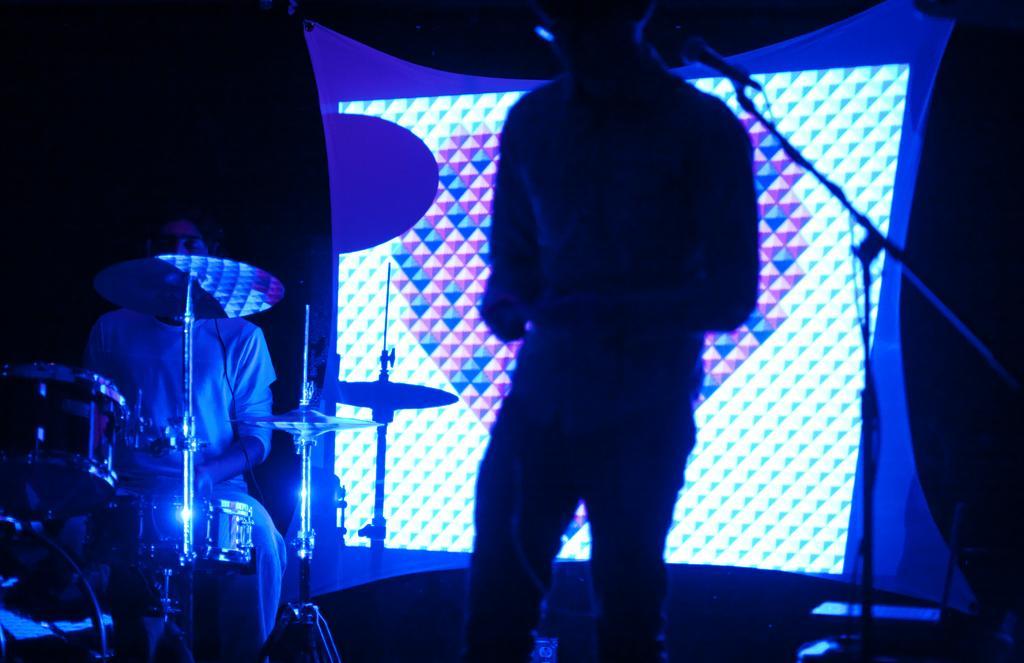Describe this image in one or two sentences. In this image we can see a person standing on the stage in front of microphone and in the background of the image there is a person who is beating drums there is white color cloth on which we can see some light. 